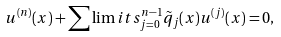<formula> <loc_0><loc_0><loc_500><loc_500>u ^ { ( n ) } ( x ) + \sum \lim i t s _ { j = 0 } ^ { n - 1 } \tilde { q } _ { j } ( x ) u ^ { ( j ) } ( x ) = 0 ,</formula> 